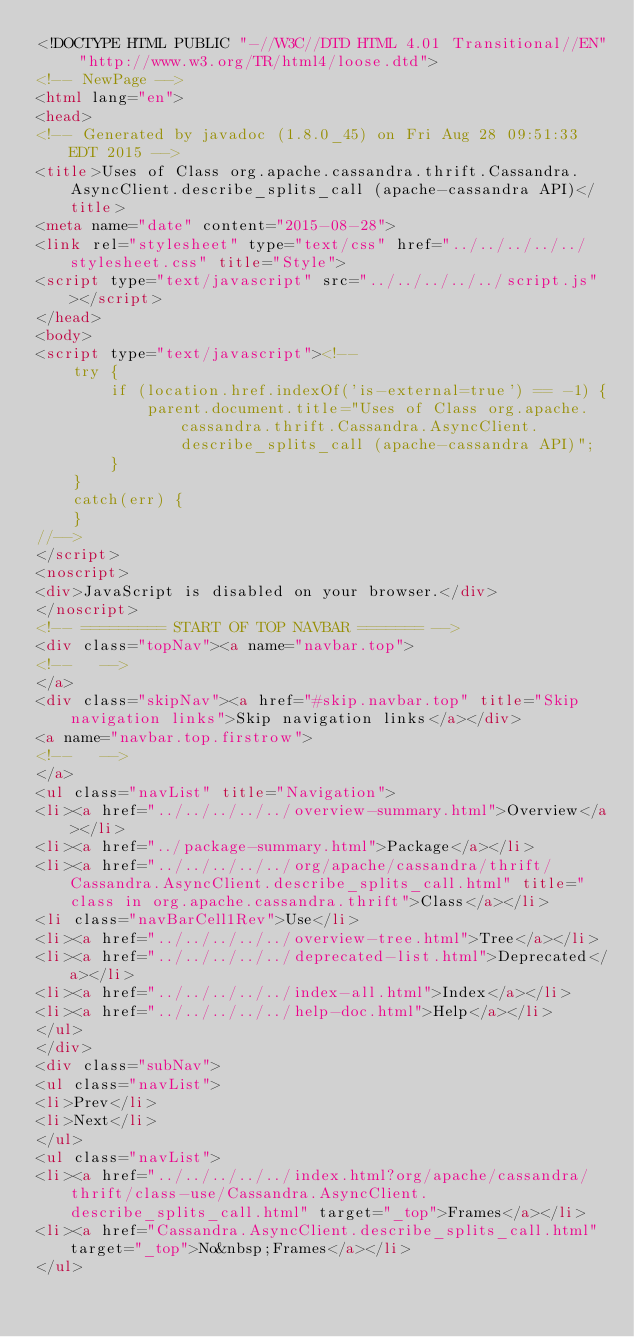<code> <loc_0><loc_0><loc_500><loc_500><_HTML_><!DOCTYPE HTML PUBLIC "-//W3C//DTD HTML 4.01 Transitional//EN" "http://www.w3.org/TR/html4/loose.dtd">
<!-- NewPage -->
<html lang="en">
<head>
<!-- Generated by javadoc (1.8.0_45) on Fri Aug 28 09:51:33 EDT 2015 -->
<title>Uses of Class org.apache.cassandra.thrift.Cassandra.AsyncClient.describe_splits_call (apache-cassandra API)</title>
<meta name="date" content="2015-08-28">
<link rel="stylesheet" type="text/css" href="../../../../../stylesheet.css" title="Style">
<script type="text/javascript" src="../../../../../script.js"></script>
</head>
<body>
<script type="text/javascript"><!--
    try {
        if (location.href.indexOf('is-external=true') == -1) {
            parent.document.title="Uses of Class org.apache.cassandra.thrift.Cassandra.AsyncClient.describe_splits_call (apache-cassandra API)";
        }
    }
    catch(err) {
    }
//-->
</script>
<noscript>
<div>JavaScript is disabled on your browser.</div>
</noscript>
<!-- ========= START OF TOP NAVBAR ======= -->
<div class="topNav"><a name="navbar.top">
<!--   -->
</a>
<div class="skipNav"><a href="#skip.navbar.top" title="Skip navigation links">Skip navigation links</a></div>
<a name="navbar.top.firstrow">
<!--   -->
</a>
<ul class="navList" title="Navigation">
<li><a href="../../../../../overview-summary.html">Overview</a></li>
<li><a href="../package-summary.html">Package</a></li>
<li><a href="../../../../../org/apache/cassandra/thrift/Cassandra.AsyncClient.describe_splits_call.html" title="class in org.apache.cassandra.thrift">Class</a></li>
<li class="navBarCell1Rev">Use</li>
<li><a href="../../../../../overview-tree.html">Tree</a></li>
<li><a href="../../../../../deprecated-list.html">Deprecated</a></li>
<li><a href="../../../../../index-all.html">Index</a></li>
<li><a href="../../../../../help-doc.html">Help</a></li>
</ul>
</div>
<div class="subNav">
<ul class="navList">
<li>Prev</li>
<li>Next</li>
</ul>
<ul class="navList">
<li><a href="../../../../../index.html?org/apache/cassandra/thrift/class-use/Cassandra.AsyncClient.describe_splits_call.html" target="_top">Frames</a></li>
<li><a href="Cassandra.AsyncClient.describe_splits_call.html" target="_top">No&nbsp;Frames</a></li>
</ul></code> 